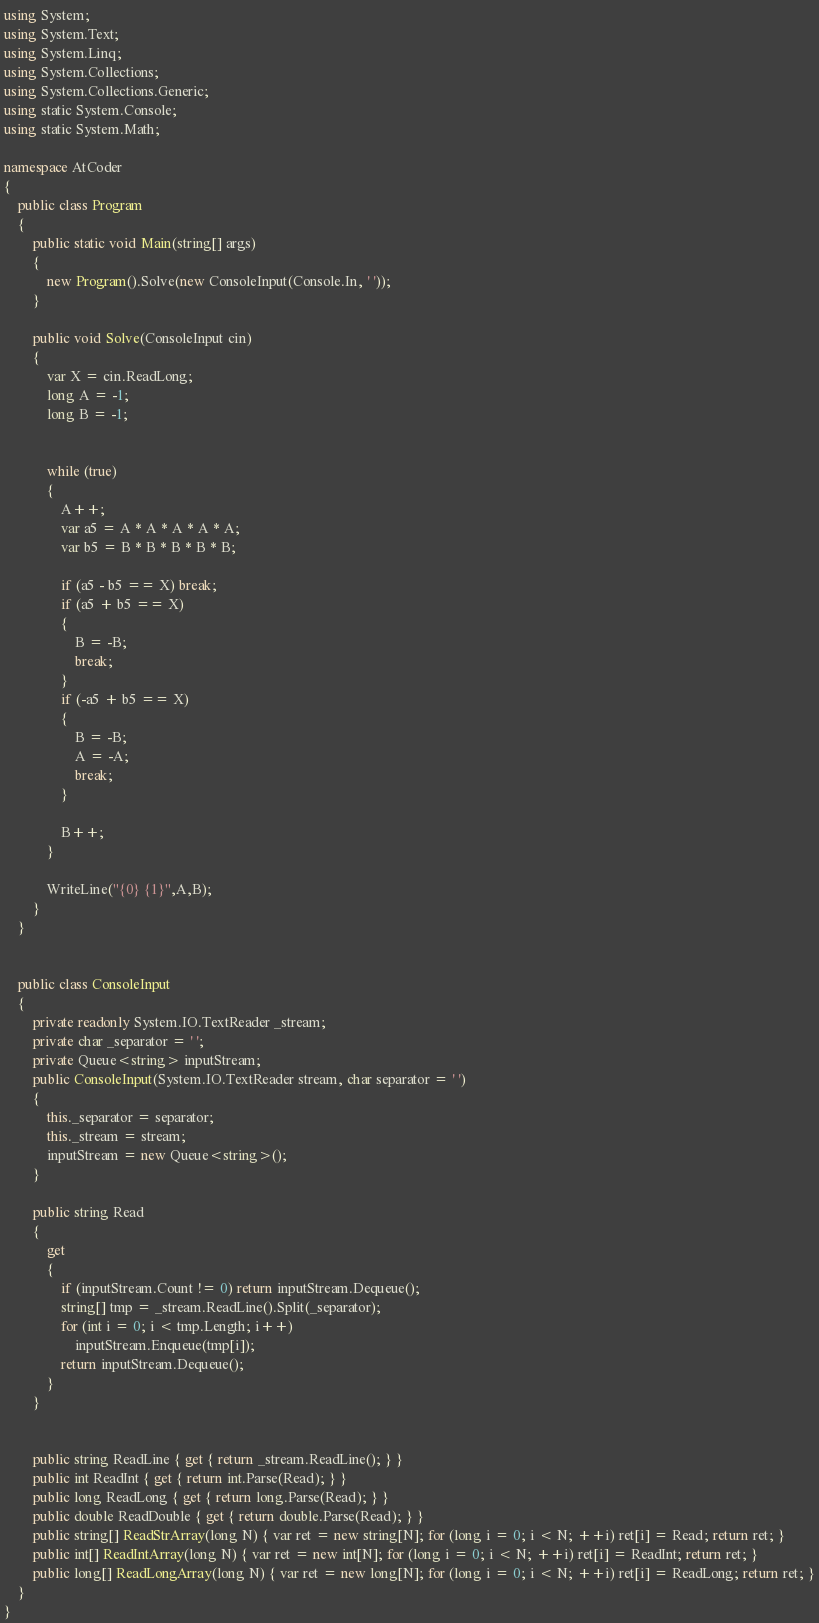<code> <loc_0><loc_0><loc_500><loc_500><_C#_>using System;
using System.Text;
using System.Linq;
using System.Collections;
using System.Collections.Generic;
using static System.Console;
using static System.Math;

namespace AtCoder
{
    public class Program
    {
        public static void Main(string[] args)
        {
            new Program().Solve(new ConsoleInput(Console.In, ' '));
        }

        public void Solve(ConsoleInput cin)
        {
            var X = cin.ReadLong;
            long A = -1;
            long B = -1;


            while (true)
            {
                A++;
                var a5 = A * A * A * A * A;
                var b5 = B * B * B * B * B;

                if (a5 - b5 == X) break;
                if (a5 + b5 == X)
                {
                    B = -B;
                    break;
                }
                if (-a5 + b5 == X)
                {
                    B = -B;
                    A = -A;
                    break;
                }

                B++;
            }

            WriteLine("{0} {1}",A,B);
        }
    }


    public class ConsoleInput
    {
        private readonly System.IO.TextReader _stream;
        private char _separator = ' ';
        private Queue<string> inputStream;
        public ConsoleInput(System.IO.TextReader stream, char separator = ' ')
        {
            this._separator = separator;
            this._stream = stream;
            inputStream = new Queue<string>();
        }

        public string Read
        {
            get
            {
                if (inputStream.Count != 0) return inputStream.Dequeue();
                string[] tmp = _stream.ReadLine().Split(_separator);
                for (int i = 0; i < tmp.Length; i++)
                    inputStream.Enqueue(tmp[i]);
                return inputStream.Dequeue();
            }
        }


        public string ReadLine { get { return _stream.ReadLine(); } }
        public int ReadInt { get { return int.Parse(Read); } }
        public long ReadLong { get { return long.Parse(Read); } }
        public double ReadDouble { get { return double.Parse(Read); } }
        public string[] ReadStrArray(long N) { var ret = new string[N]; for (long i = 0; i < N; ++i) ret[i] = Read; return ret; }
        public int[] ReadIntArray(long N) { var ret = new int[N]; for (long i = 0; i < N; ++i) ret[i] = ReadInt; return ret; }
        public long[] ReadLongArray(long N) { var ret = new long[N]; for (long i = 0; i < N; ++i) ret[i] = ReadLong; return ret; }
    }
}
</code> 